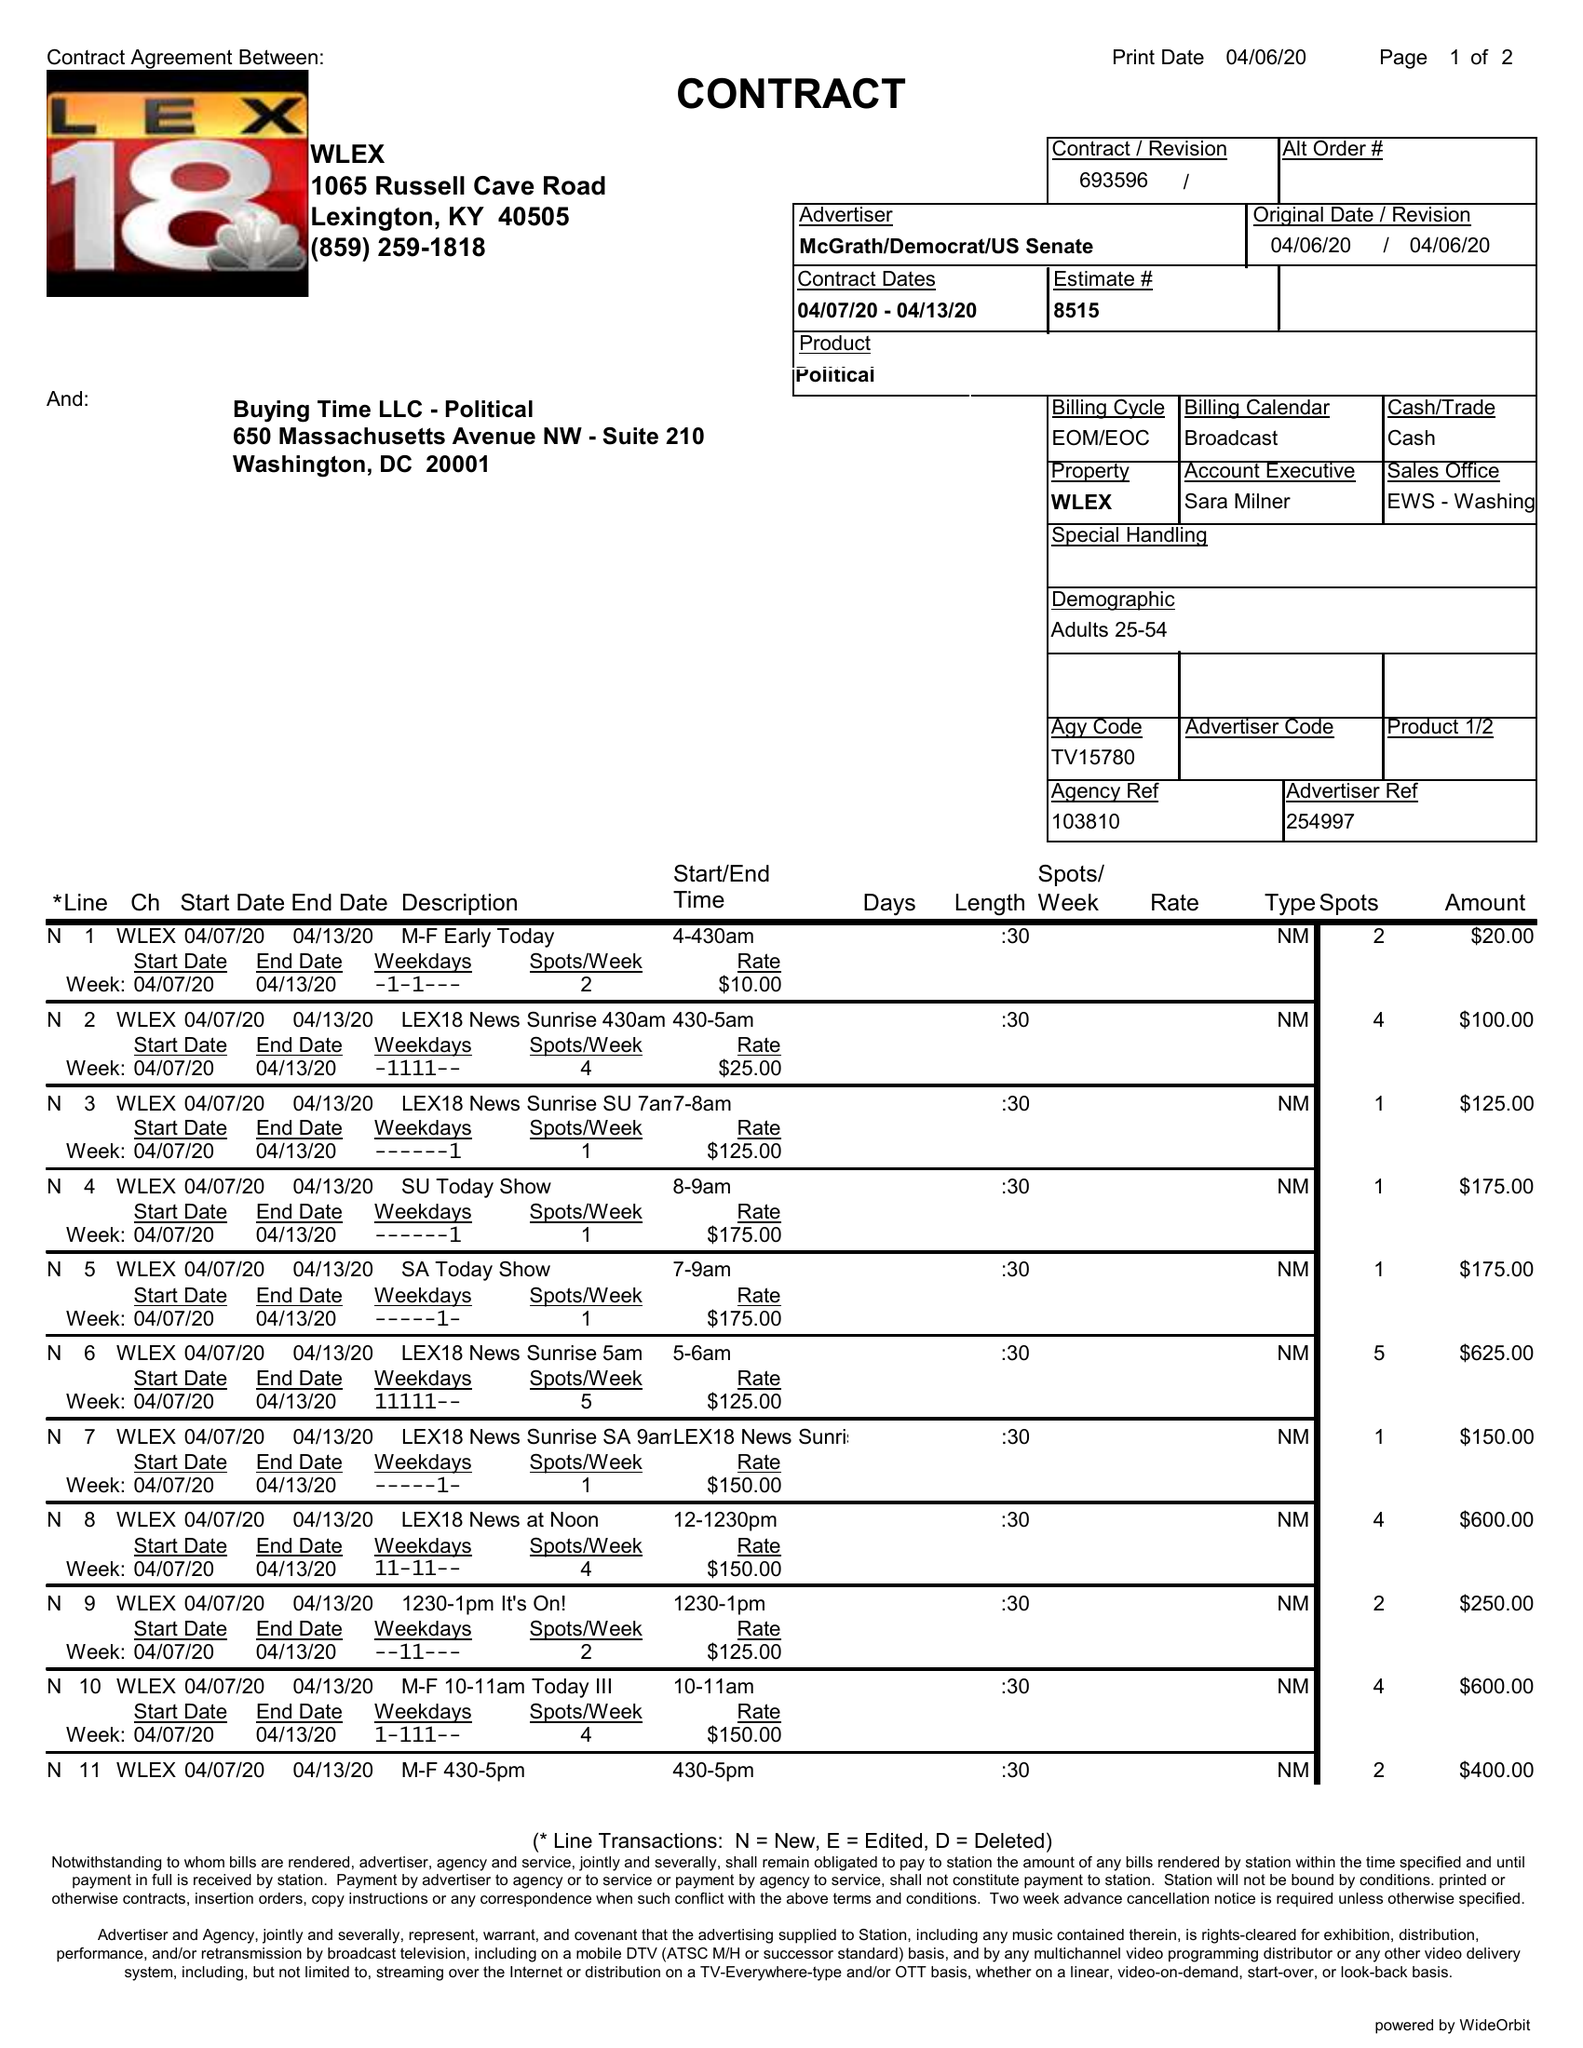What is the value for the contract_num?
Answer the question using a single word or phrase. 693596 